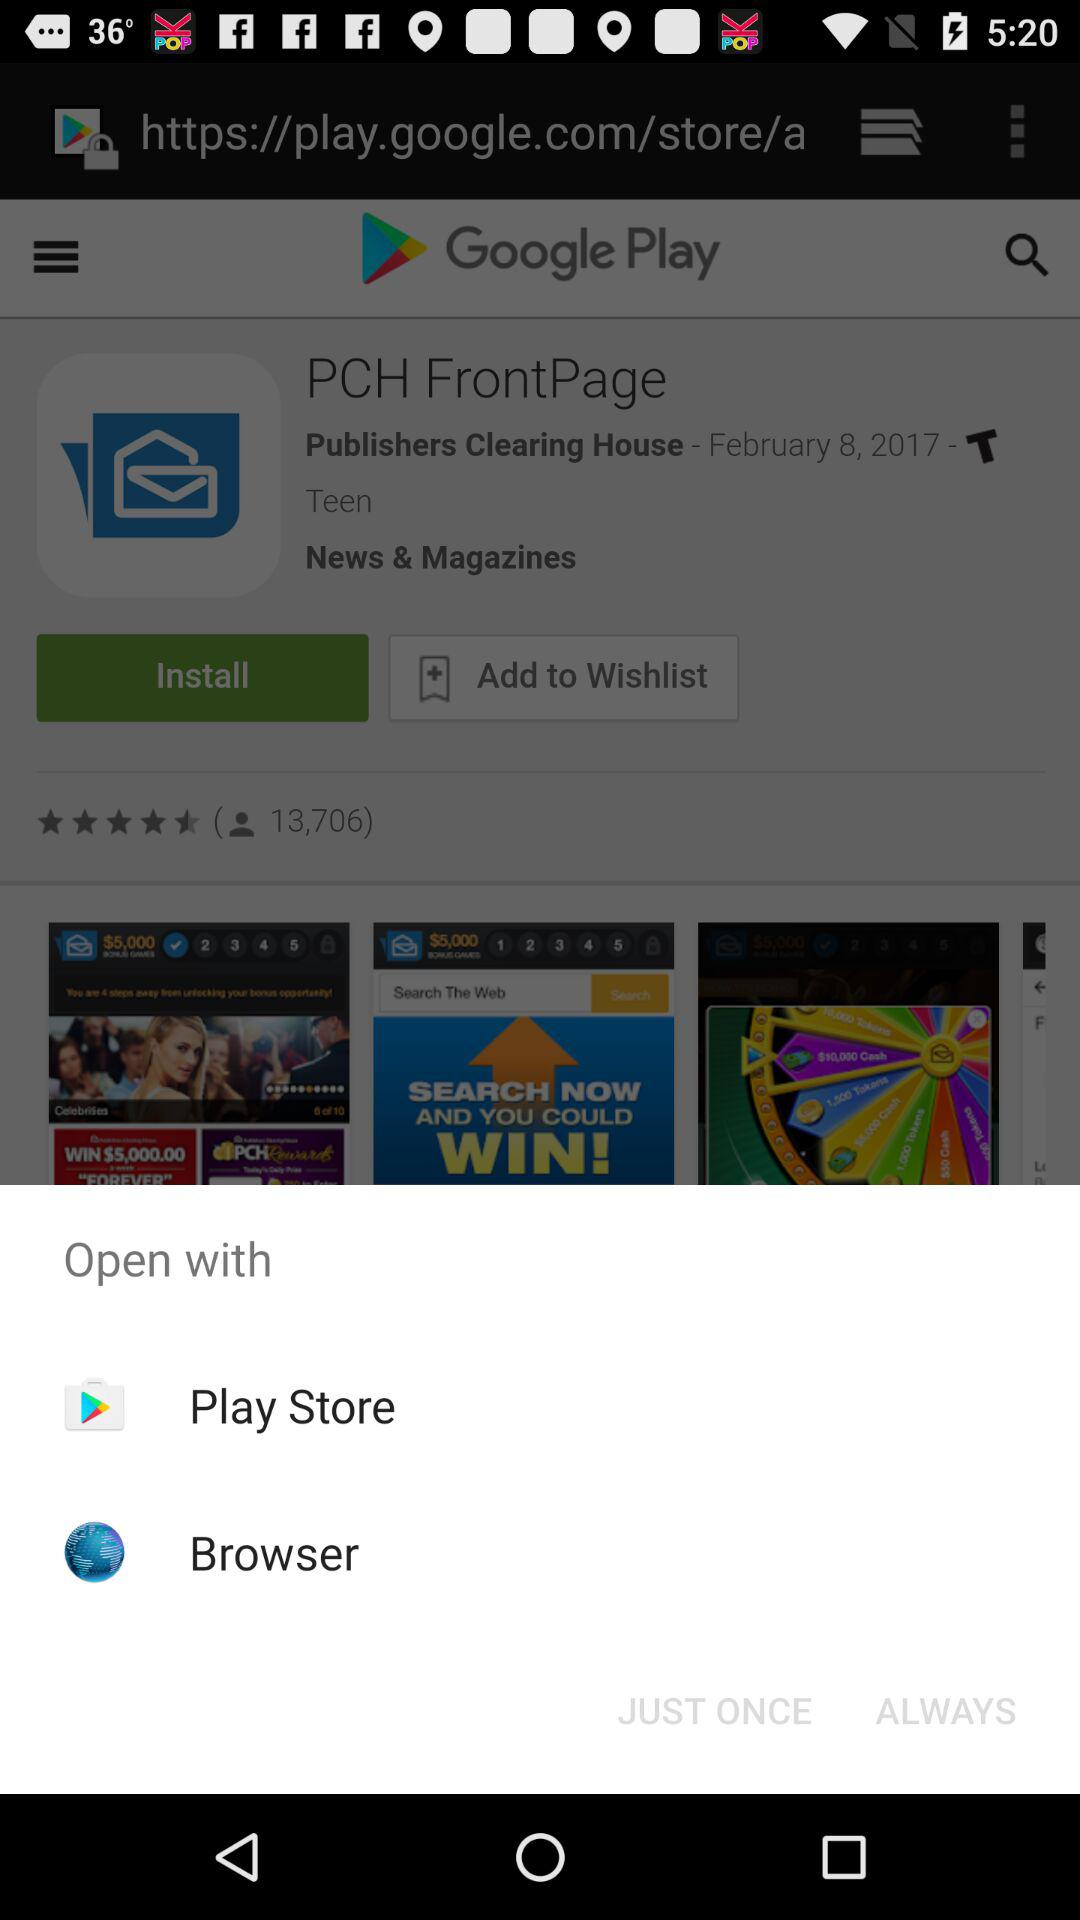Which applications can be used to open? The applications that can be used to open are "Play Store" and "Browser". 